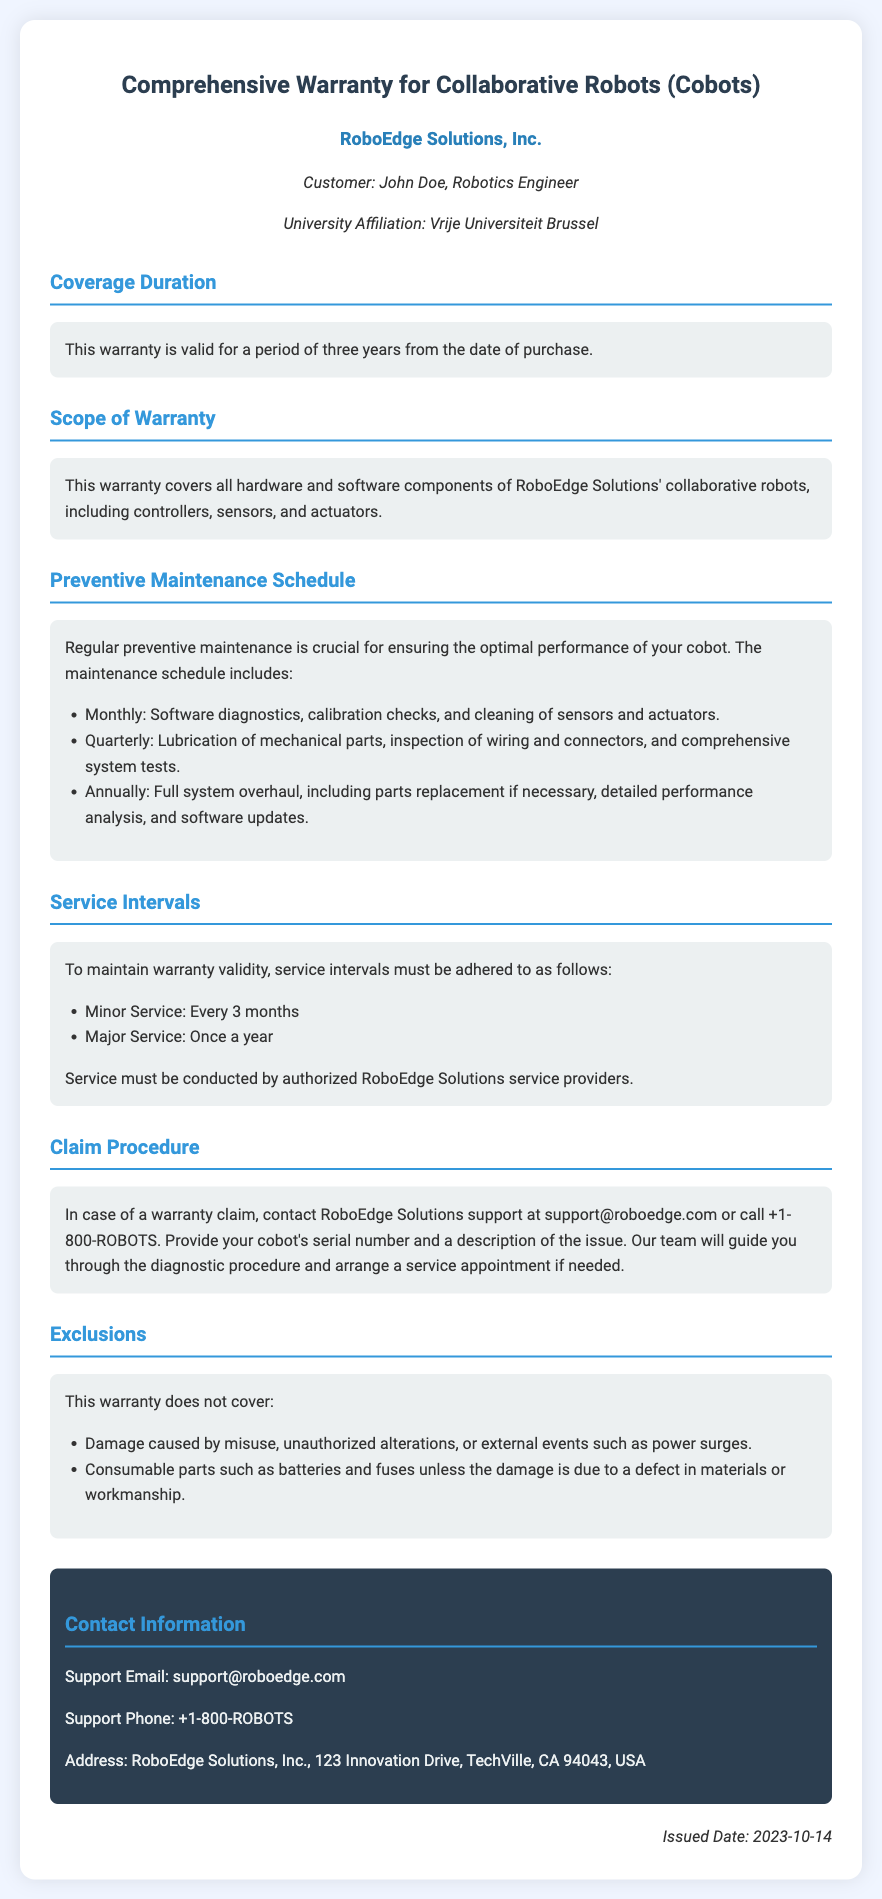What is the name of the company? The company's name is stated at the top of the document under the title.
Answer: RoboEdge Solutions, Inc What is the duration of the warranty? The warranty duration is mentioned clearly under the coverage duration section.
Answer: Three years What components are covered under the warranty? The scope of warranty section lists what is included in the coverage.
Answer: All hardware and software components How often is minor service required? The service intervals section specifies the frequency for minor service tasks.
Answer: Every 3 months What is required for a warranty claim? The claim procedure section explains what information must be provided for a claim.
Answer: Cobot's serial number and a description of the issue What is excluded from the warranty? The exclusions section outlines what is not covered under the warranty.
Answer: Damage caused by misuse What must service intervals be conducted by? The service intervals section concludes with a requirement for who must conduct the services.
Answer: Authorized RoboEdge Solutions service providers When was the warranty issued? The issued date is mentioned at the bottom of the document.
Answer: 2023-10-14 What is the support email provided in the document? The contact information section lists how to get support via email.
Answer: support@roboedge.com What must be checked monthly during preventive maintenance? The preventive maintenance schedule details what needs to be checked monthly.
Answer: Software diagnostics, calibration checks, and cleaning of sensors and actuators 